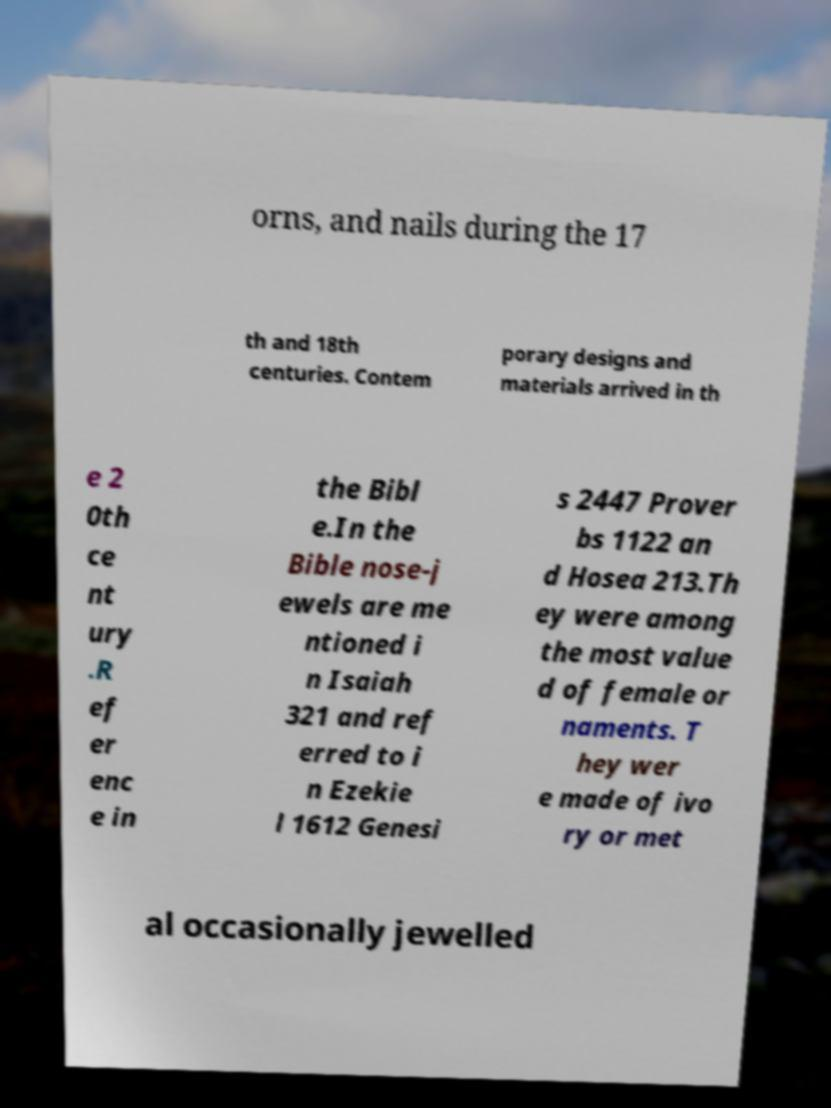Can you read and provide the text displayed in the image?This photo seems to have some interesting text. Can you extract and type it out for me? orns, and nails during the 17 th and 18th centuries. Contem porary designs and materials arrived in th e 2 0th ce nt ury .R ef er enc e in the Bibl e.In the Bible nose-j ewels are me ntioned i n Isaiah 321 and ref erred to i n Ezekie l 1612 Genesi s 2447 Prover bs 1122 an d Hosea 213.Th ey were among the most value d of female or naments. T hey wer e made of ivo ry or met al occasionally jewelled 